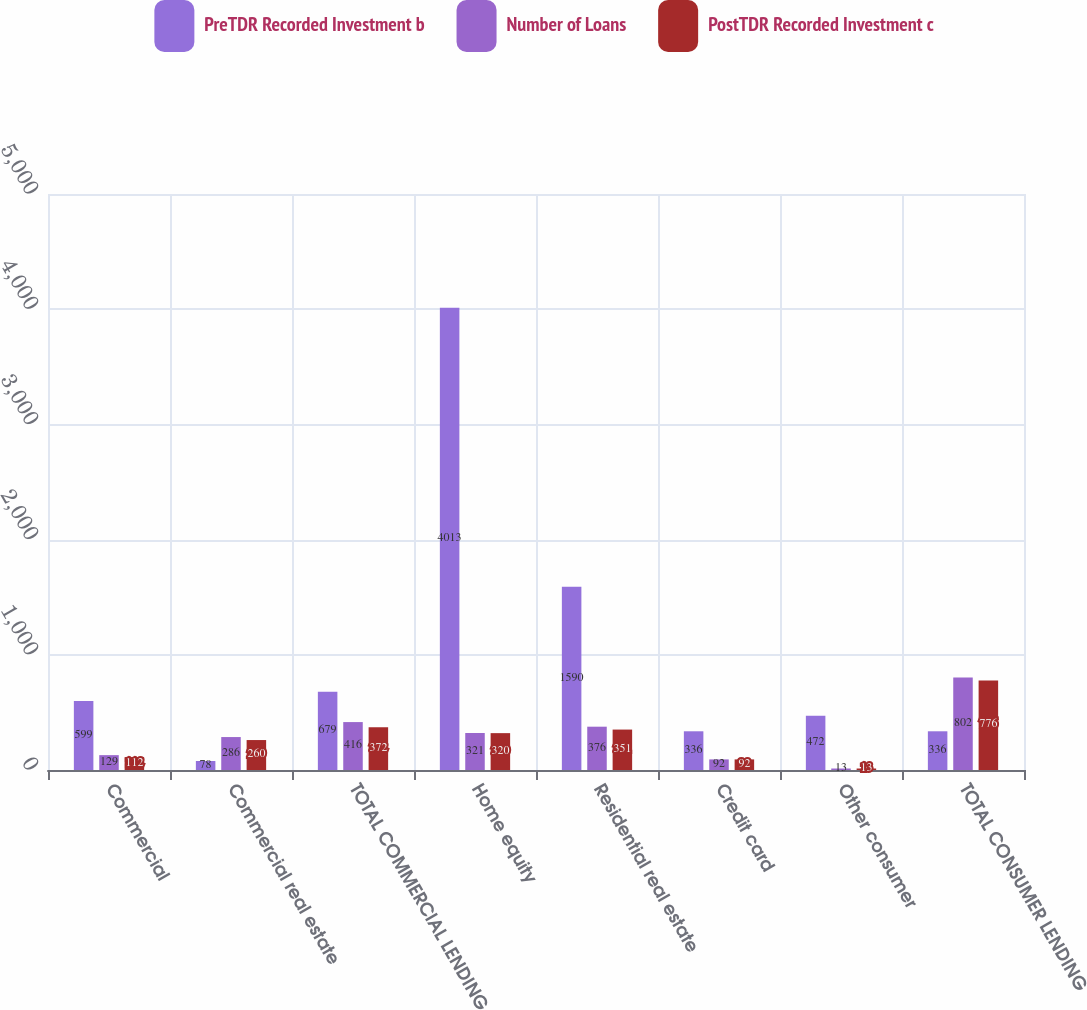<chart> <loc_0><loc_0><loc_500><loc_500><stacked_bar_chart><ecel><fcel>Commercial<fcel>Commercial real estate<fcel>TOTAL COMMERCIAL LENDING<fcel>Home equity<fcel>Residential real estate<fcel>Credit card<fcel>Other consumer<fcel>TOTAL CONSUMER LENDING<nl><fcel>PreTDR Recorded Investment b<fcel>599<fcel>78<fcel>679<fcel>4013<fcel>1590<fcel>336<fcel>472<fcel>336<nl><fcel>Number of Loans<fcel>129<fcel>286<fcel>416<fcel>321<fcel>376<fcel>92<fcel>13<fcel>802<nl><fcel>PostTDR Recorded Investment c<fcel>112<fcel>260<fcel>372<fcel>320<fcel>351<fcel>92<fcel>13<fcel>776<nl></chart> 